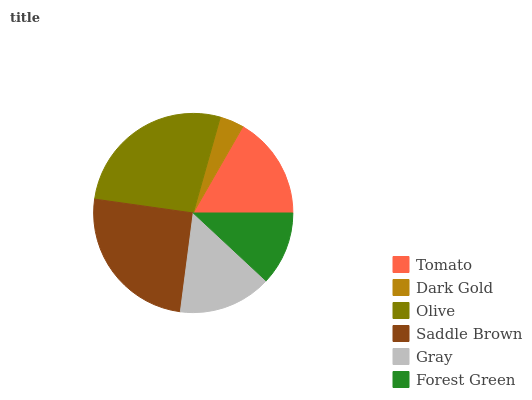Is Dark Gold the minimum?
Answer yes or no. Yes. Is Olive the maximum?
Answer yes or no. Yes. Is Olive the minimum?
Answer yes or no. No. Is Dark Gold the maximum?
Answer yes or no. No. Is Olive greater than Dark Gold?
Answer yes or no. Yes. Is Dark Gold less than Olive?
Answer yes or no. Yes. Is Dark Gold greater than Olive?
Answer yes or no. No. Is Olive less than Dark Gold?
Answer yes or no. No. Is Tomato the high median?
Answer yes or no. Yes. Is Gray the low median?
Answer yes or no. Yes. Is Dark Gold the high median?
Answer yes or no. No. Is Saddle Brown the low median?
Answer yes or no. No. 